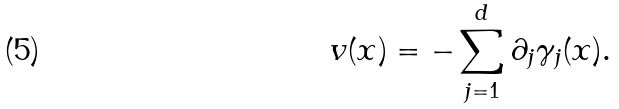<formula> <loc_0><loc_0><loc_500><loc_500>v ( x ) = - \sum _ { j = 1 } ^ { d } \partial _ { j } \gamma _ { j } ( x ) .</formula> 